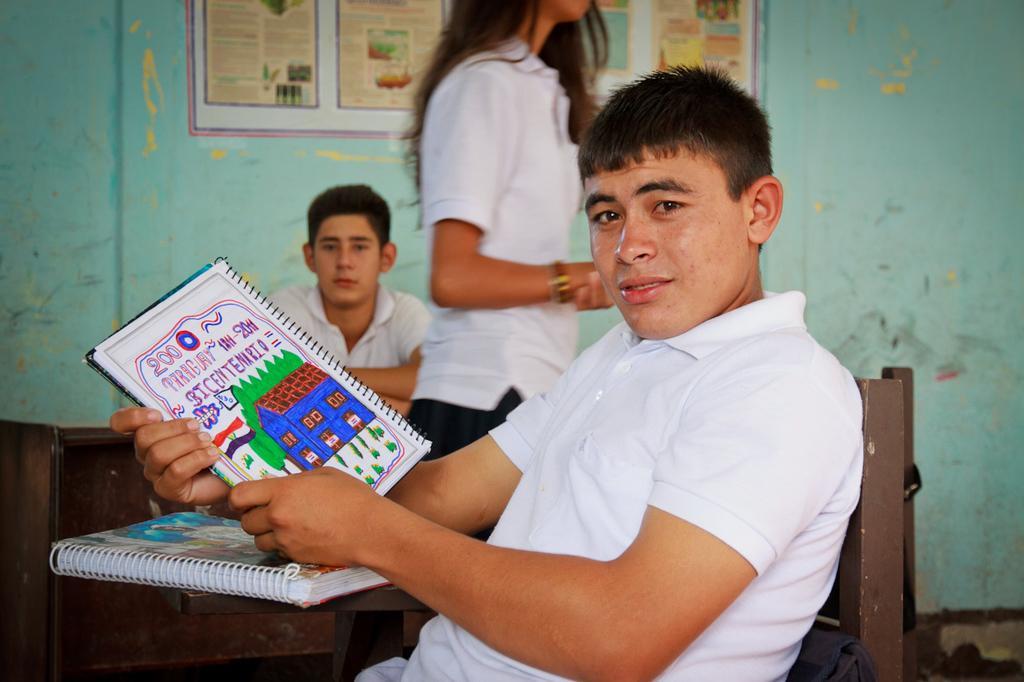How would you summarize this image in a sentence or two? In this image there are two men sitting on a chair, one man is holding a book in his hand, in between them there is a lady, in the background there is a wall to that wall there is a poster. 